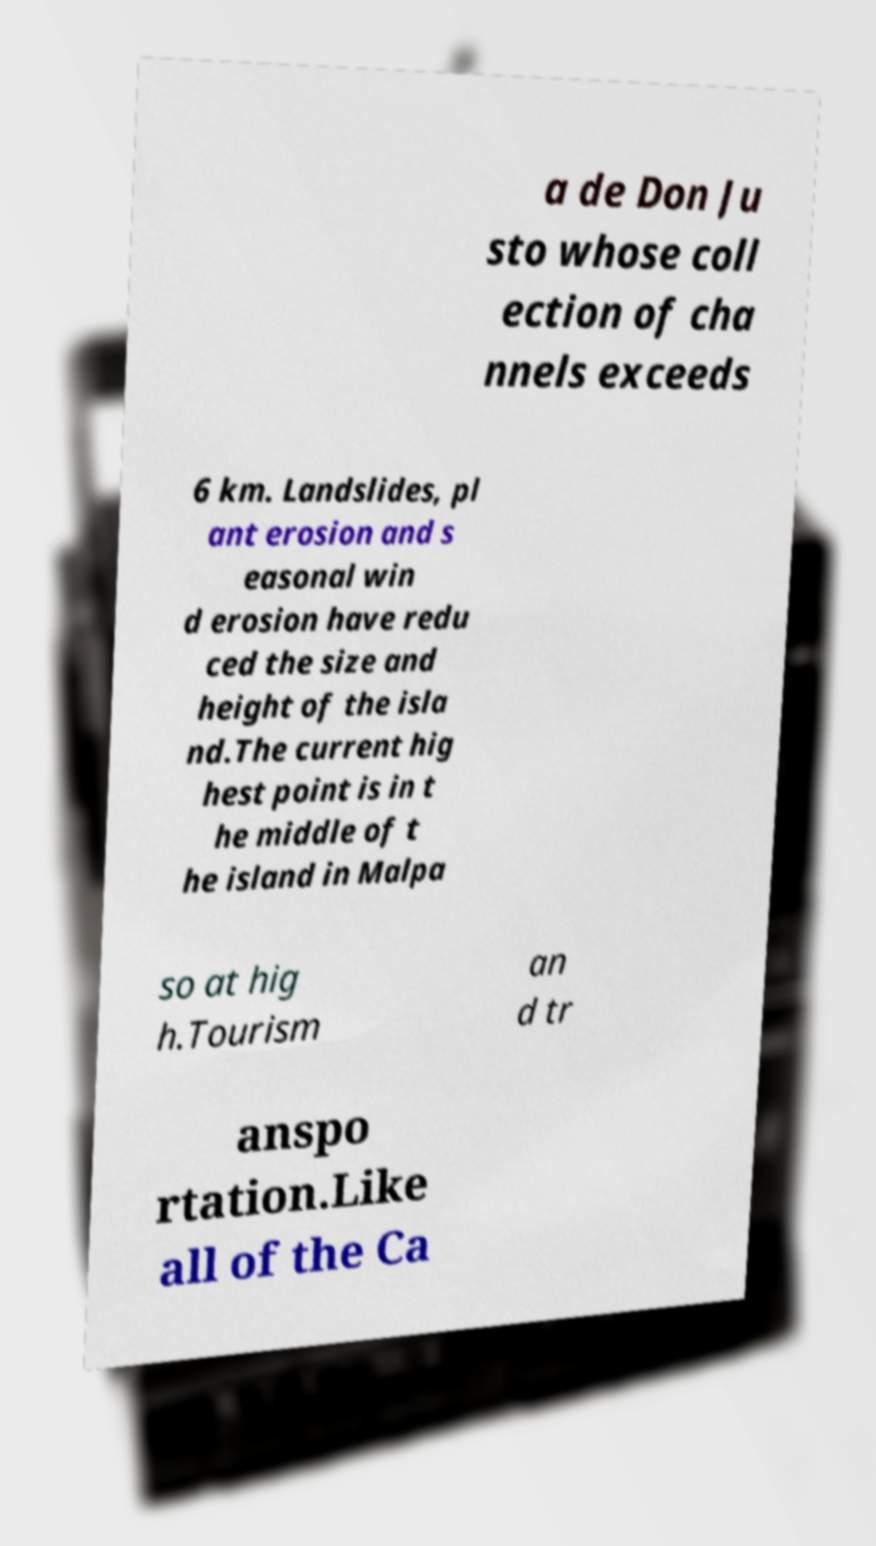I need the written content from this picture converted into text. Can you do that? a de Don Ju sto whose coll ection of cha nnels exceeds 6 km. Landslides, pl ant erosion and s easonal win d erosion have redu ced the size and height of the isla nd.The current hig hest point is in t he middle of t he island in Malpa so at hig h.Tourism an d tr anspo rtation.Like all of the Ca 